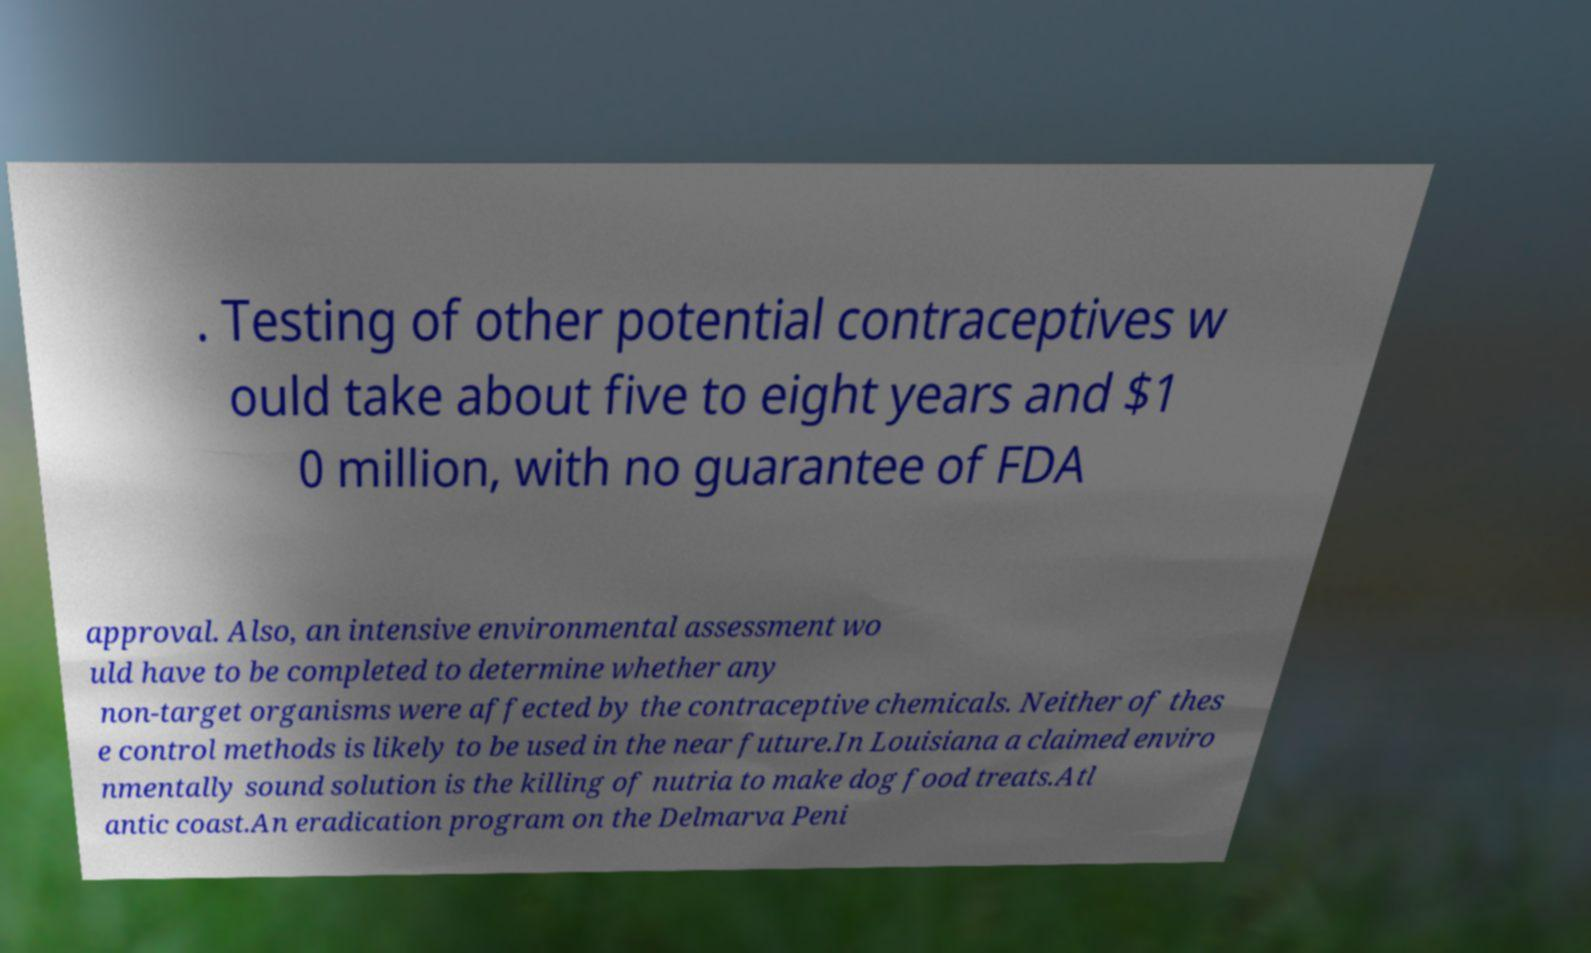There's text embedded in this image that I need extracted. Can you transcribe it verbatim? . Testing of other potential contraceptives w ould take about five to eight years and $1 0 million, with no guarantee of FDA approval. Also, an intensive environmental assessment wo uld have to be completed to determine whether any non-target organisms were affected by the contraceptive chemicals. Neither of thes e control methods is likely to be used in the near future.In Louisiana a claimed enviro nmentally sound solution is the killing of nutria to make dog food treats.Atl antic coast.An eradication program on the Delmarva Peni 